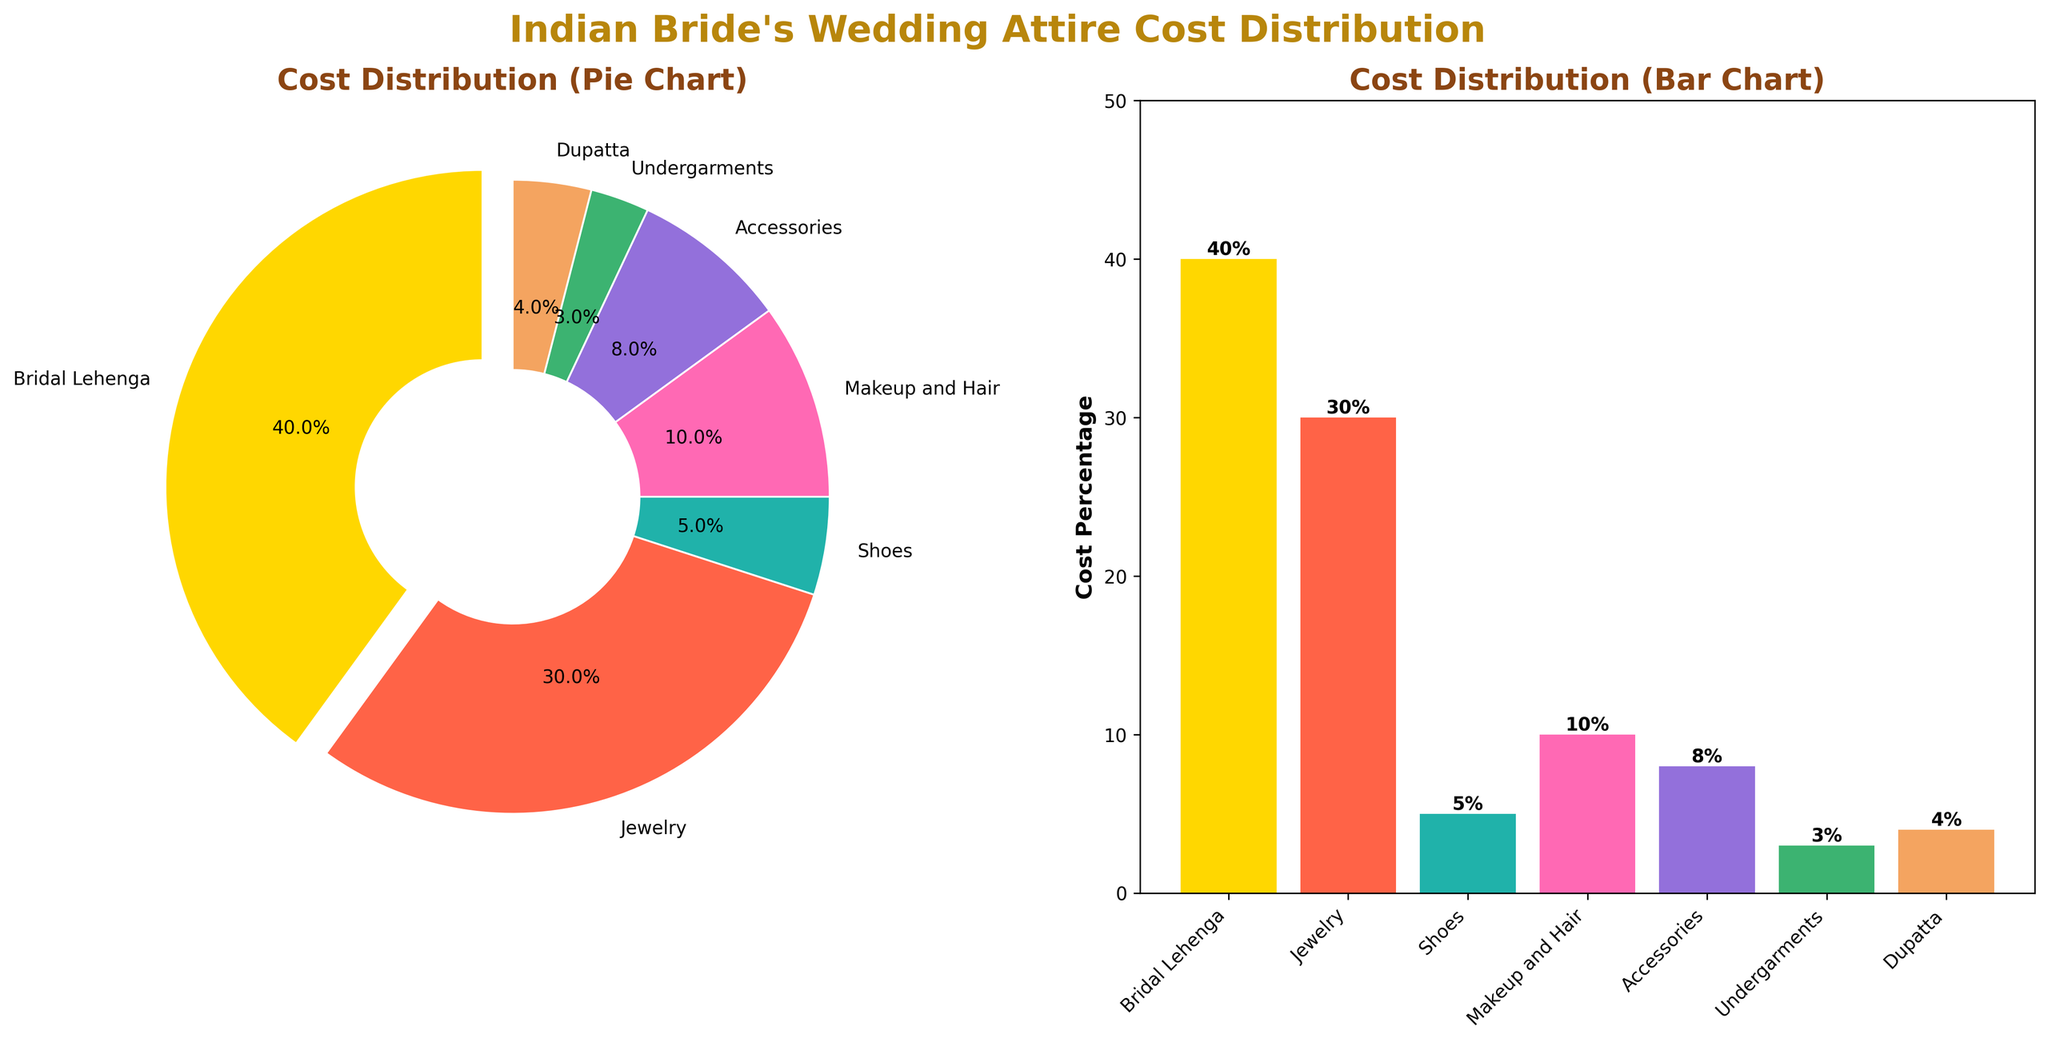What's the title of the figure? The figure has a main title at the top of the entire figure. By looking at the figure, the title is mentioned prominently in bold and large font.
Answer: Indian Bride's Wedding Attire Cost Distribution How is the cost distributed between the Bridal Lehenga, Jewelry, and Accessories? To answer this, add the cost percentages of Bridal Lehenga (40%), Jewelry (30%), and Accessories (8%). 40% + 30% + 8% = 78%.
Answer: 78% Which component has the lowest cost percentage? By observing both the pie chart and the bar chart, we can see that Undergarments have the smallest wedge in the pie chart and the shortest bar in the bar chart. The cost percentage of Undergarments is 3%.
Answer: Undergarments How much more percentage is spent on Jewelry compared to Makeup and Hair? To find this, subtract the cost percentage of Makeup and Hair (10%) from Jewelry (30%). 30% - 10% = 20%.
Answer: 20% What is the combined cost percentage of Shoes and Dupatta? By adding the cost percentages of Shoes (5%) and Dupatta (4%), we get 5% + 4% = 9%.
Answer: 9% Which component has the second highest cost percentage? By looking at both the pie chart and the bar chart, we can see that after Bridal Lehenga (40%), Jewelry has the highest cost percentage at 30%.
Answer: Jewelry What color is used to represent the Bridal Lehenga in the pie chart? By examining the color legend and the corresponding wedge in the pie chart, we can see that Bridal Lehenga is represented by a golden color.
Answer: Golden How does the height of the bar representing Accessories compare to that of Makeup and Hair? By comparing the bars in the bar chart, we see that the bar for Accessories is slightly shorter than the bar for Makeup and Hair. Accessories are at 8%, while Makeup and Hair are at 10%.
Answer: Accessories are shorter Which components are represented by the two smallest wedges in the pie chart? By looking at the pie chart, the two smallest wedges are for Undergarments (3%) and Dupatta (4%).
Answer: Undergarments and Dupatta 